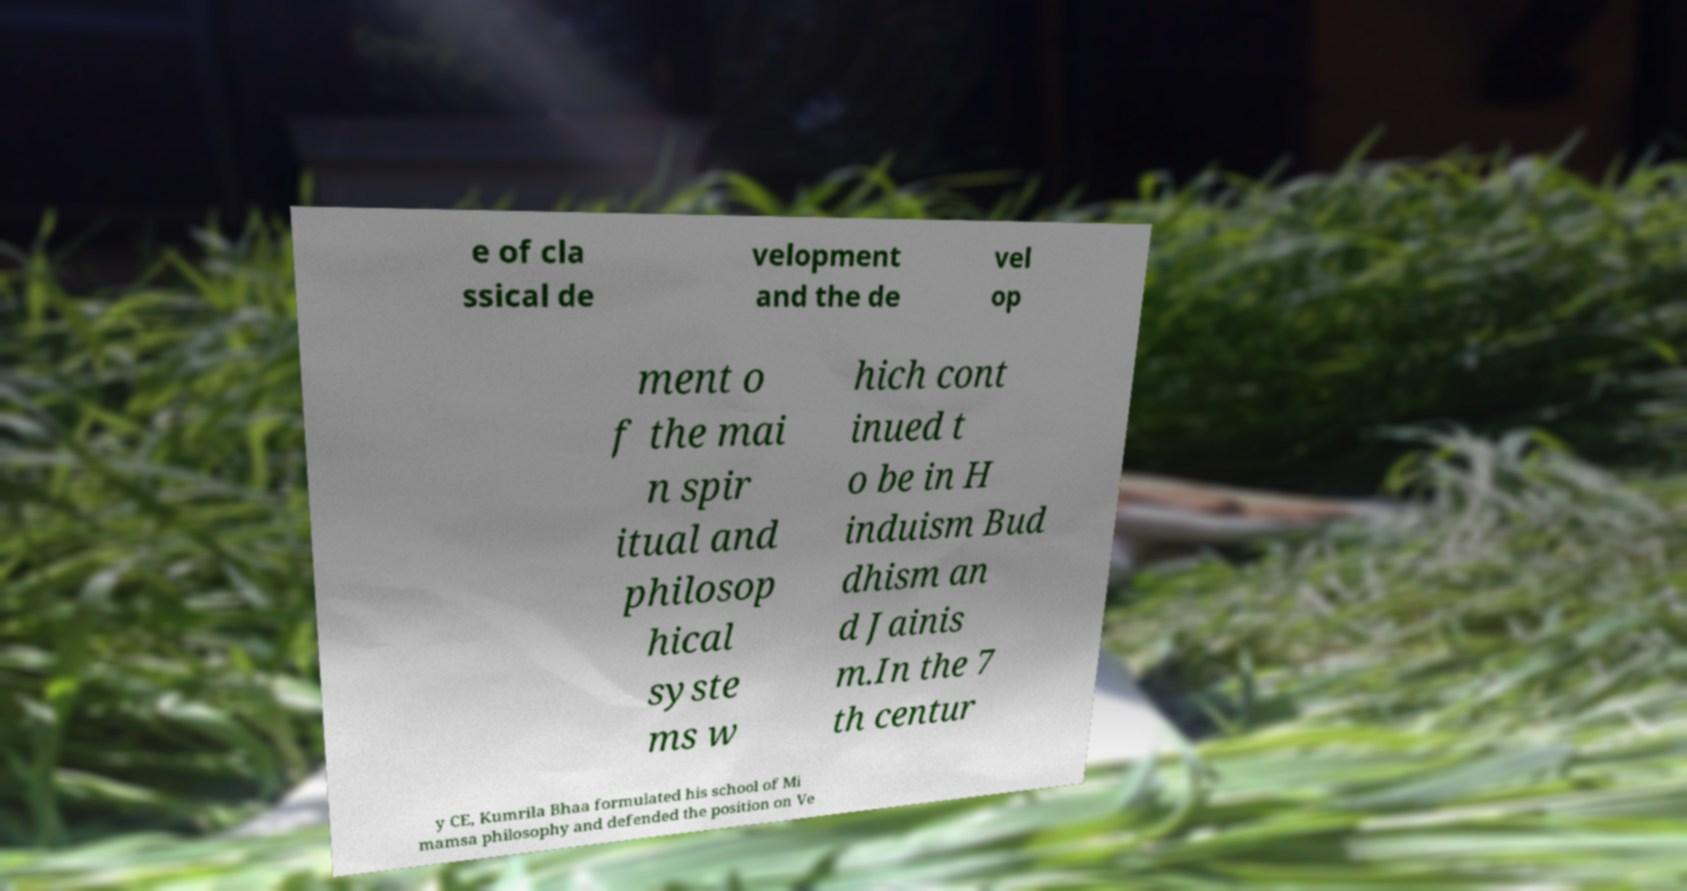Can you accurately transcribe the text from the provided image for me? e of cla ssical de velopment and the de vel op ment o f the mai n spir itual and philosop hical syste ms w hich cont inued t o be in H induism Bud dhism an d Jainis m.In the 7 th centur y CE, Kumrila Bhaa formulated his school of Mi mamsa philosophy and defended the position on Ve 